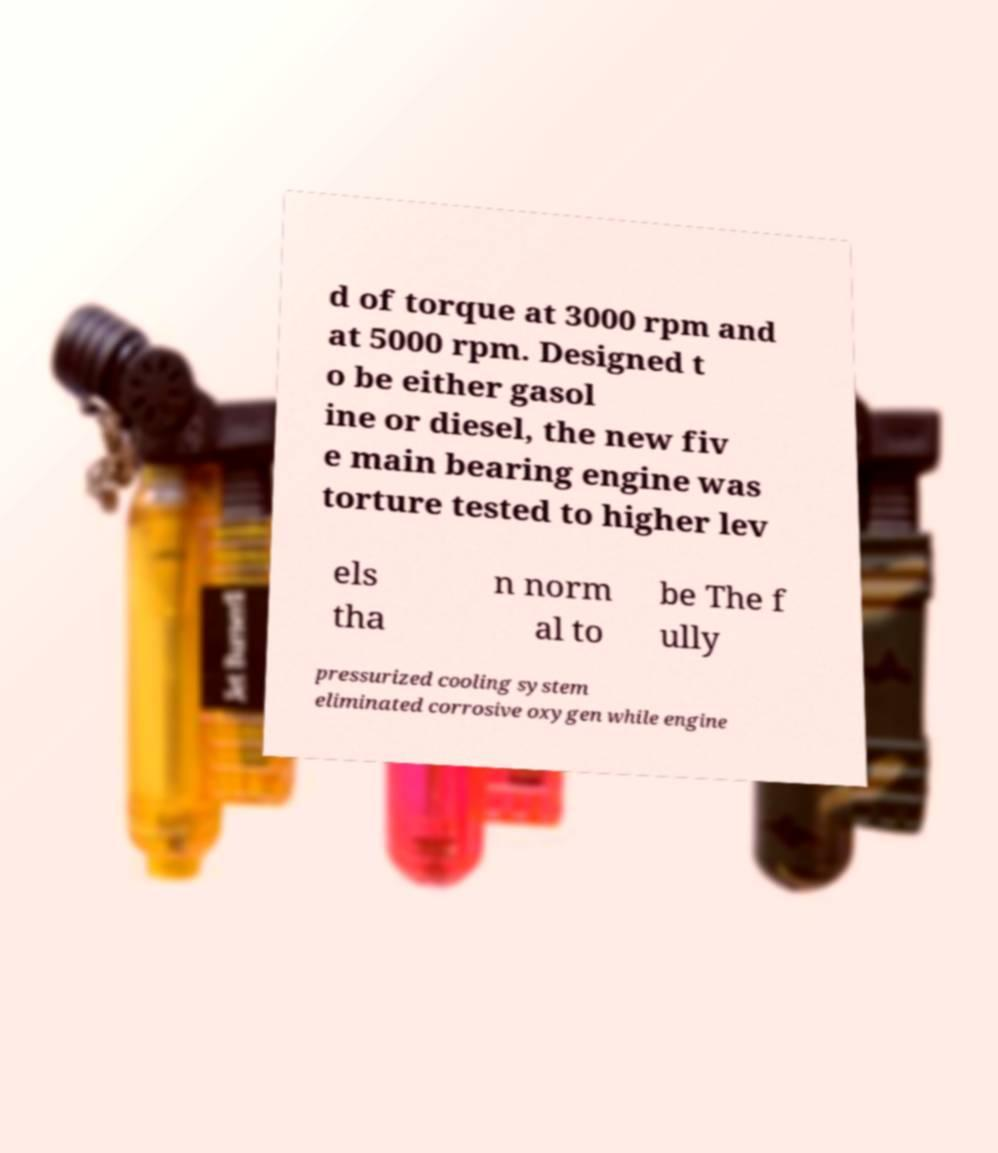I need the written content from this picture converted into text. Can you do that? d of torque at 3000 rpm and at 5000 rpm. Designed t o be either gasol ine or diesel, the new fiv e main bearing engine was torture tested to higher lev els tha n norm al to be The f ully pressurized cooling system eliminated corrosive oxygen while engine 